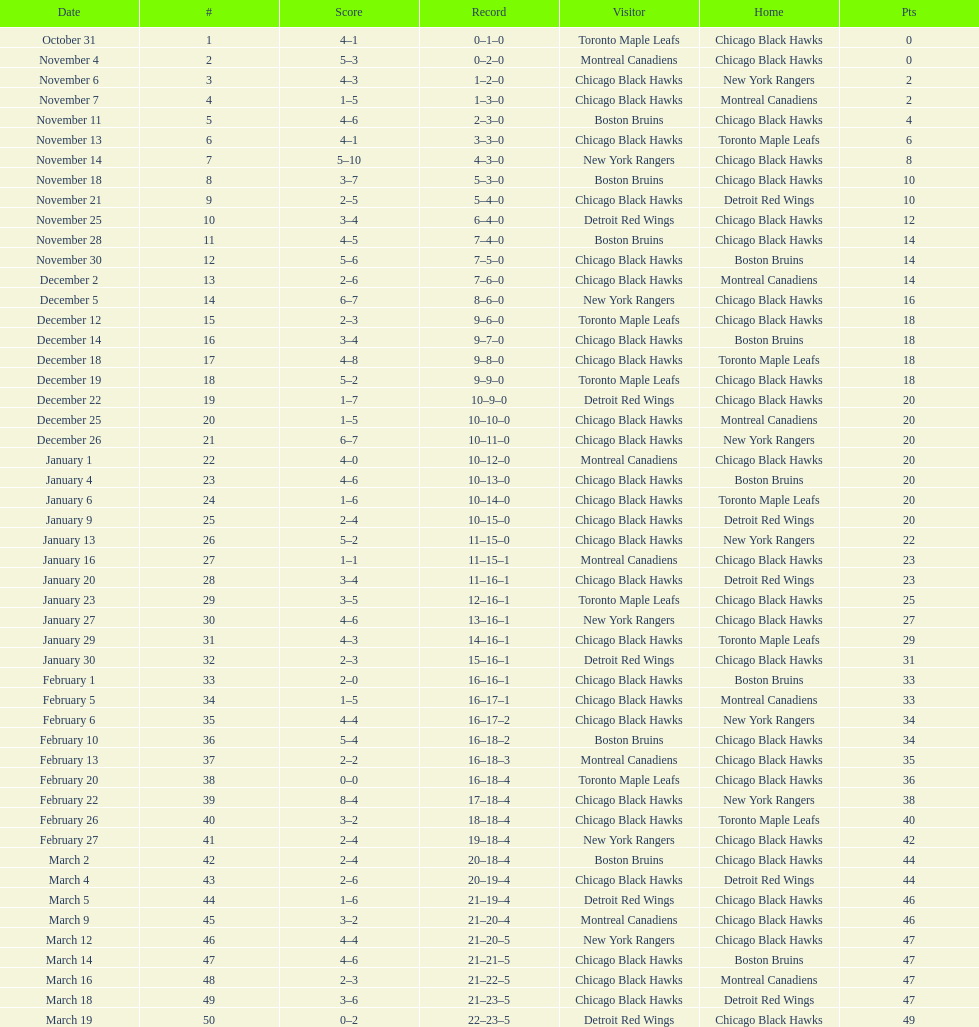What is was the difference in score in the december 19th win? 3. 